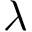Convert formula to latex. <formula><loc_0><loc_0><loc_500><loc_500>\lambda</formula> 